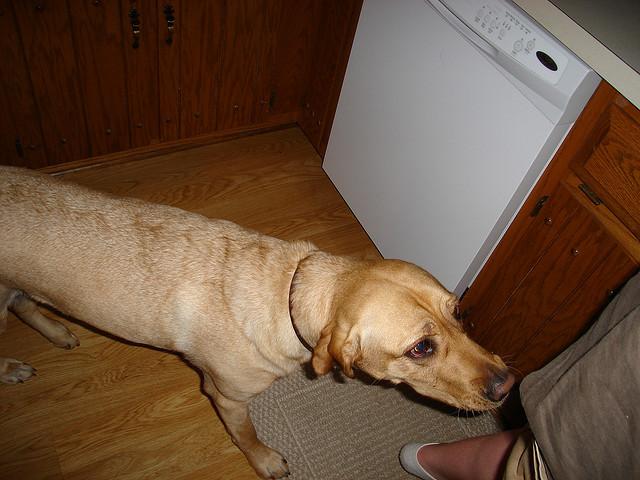Is the dog happy?
Give a very brief answer. No. What appliance is shown?
Write a very short answer. Dishwasher. Is the dog behaving well?
Short answer required. Yes. What is the dog smelling?
Keep it brief. Person. Is there a sock visible?
Quick response, please. Yes. 